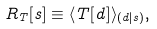Convert formula to latex. <formula><loc_0><loc_0><loc_500><loc_500>R _ { T } [ s ] \equiv \langle T [ d ] \rangle _ { ( d | s ) } ,</formula> 